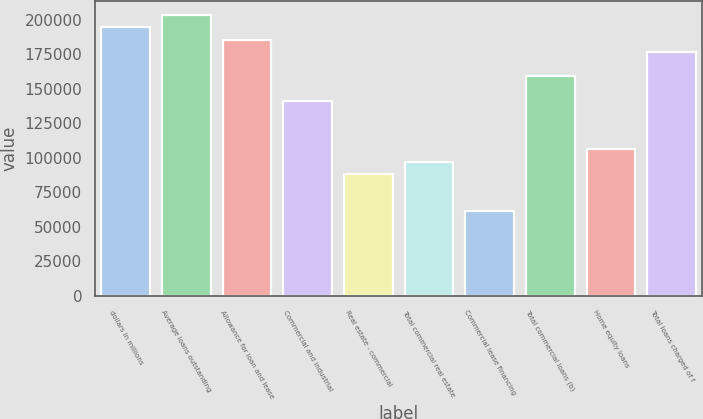<chart> <loc_0><loc_0><loc_500><loc_500><bar_chart><fcel>dollars in millions<fcel>Average loans outstanding<fcel>Allowance for loan and lease<fcel>Commercial and industrial<fcel>Real estate - commercial<fcel>Total commercial real estate<fcel>Commercial lease financing<fcel>Total commercial loans (b)<fcel>Home equity loans<fcel>Total loans charged of f<nl><fcel>194342<fcel>203176<fcel>185509<fcel>141340<fcel>88338<fcel>97171.7<fcel>61836.9<fcel>159008<fcel>106005<fcel>176675<nl></chart> 